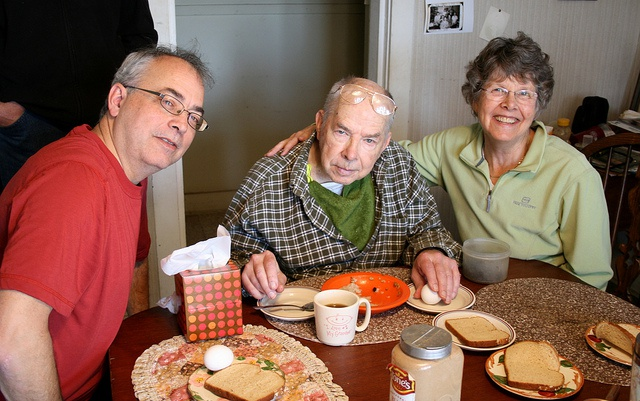Describe the objects in this image and their specific colors. I can see dining table in black, maroon, tan, and gray tones, people in black, brown, and tan tones, people in black, gray, darkgreen, and lightpink tones, people in black, tan, and gray tones, and people in black, maroon, and brown tones in this image. 